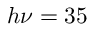Convert formula to latex. <formula><loc_0><loc_0><loc_500><loc_500>h \nu = 3 5</formula> 